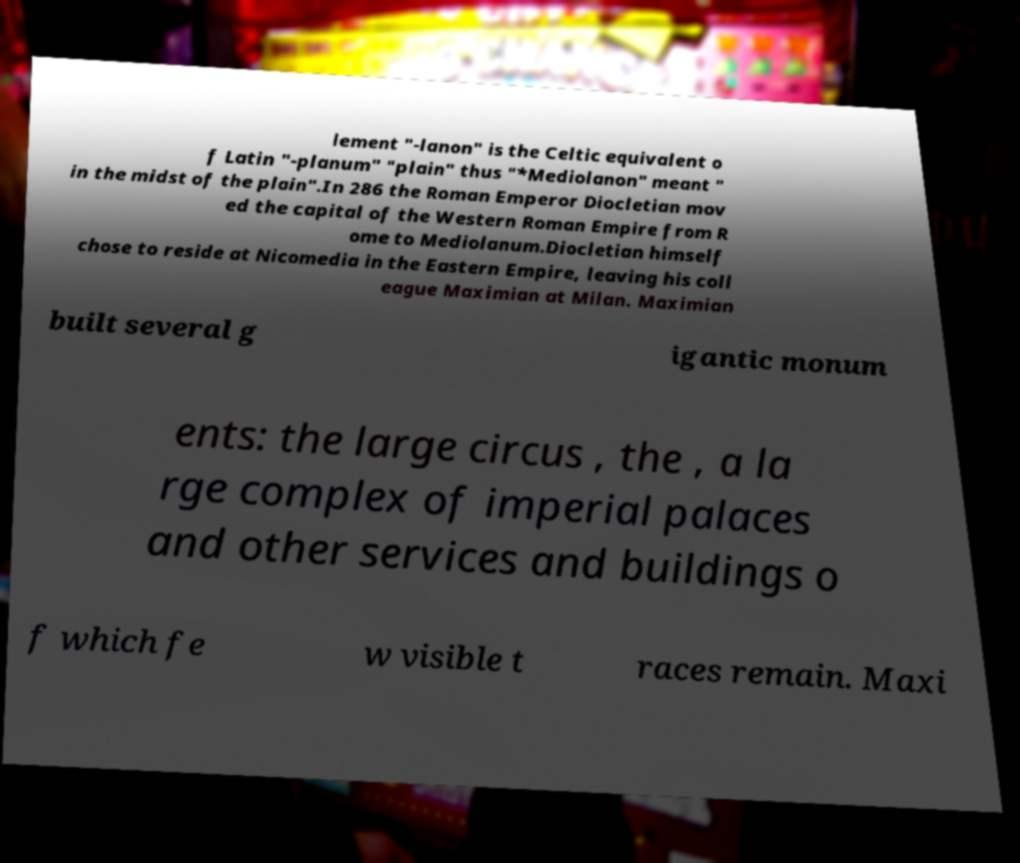Please read and relay the text visible in this image. What does it say? lement "-lanon" is the Celtic equivalent o f Latin "-planum" "plain" thus "*Mediolanon" meant " in the midst of the plain".In 286 the Roman Emperor Diocletian mov ed the capital of the Western Roman Empire from R ome to Mediolanum.Diocletian himself chose to reside at Nicomedia in the Eastern Empire, leaving his coll eague Maximian at Milan. Maximian built several g igantic monum ents: the large circus , the , a la rge complex of imperial palaces and other services and buildings o f which fe w visible t races remain. Maxi 